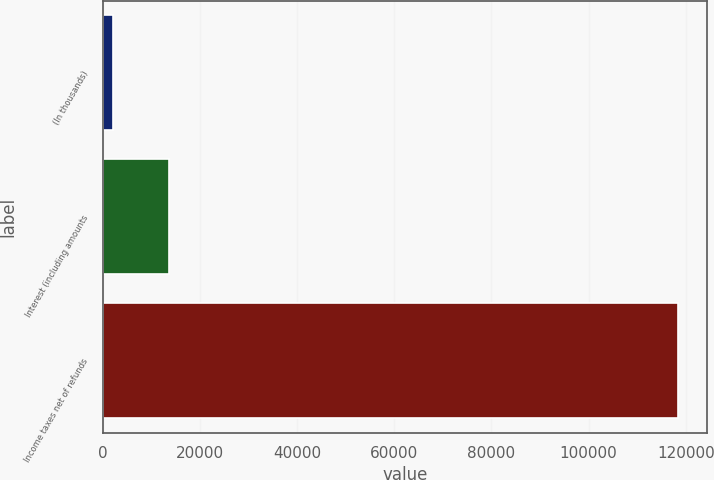Convert chart to OTSL. <chart><loc_0><loc_0><loc_500><loc_500><bar_chart><fcel>(In thousands)<fcel>Interest (including amounts<fcel>Income taxes net of refunds<nl><fcel>2015<fcel>13654.4<fcel>118409<nl></chart> 